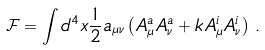<formula> <loc_0><loc_0><loc_500><loc_500>\mathcal { F } = \int { d ^ { 4 } x } \frac { 1 } { 2 } a _ { \mu \nu } \left ( A _ { \mu } ^ { a } A _ { \nu } ^ { a } + k A _ { \mu } ^ { i } A _ { \nu } ^ { i } \right ) \, .</formula> 